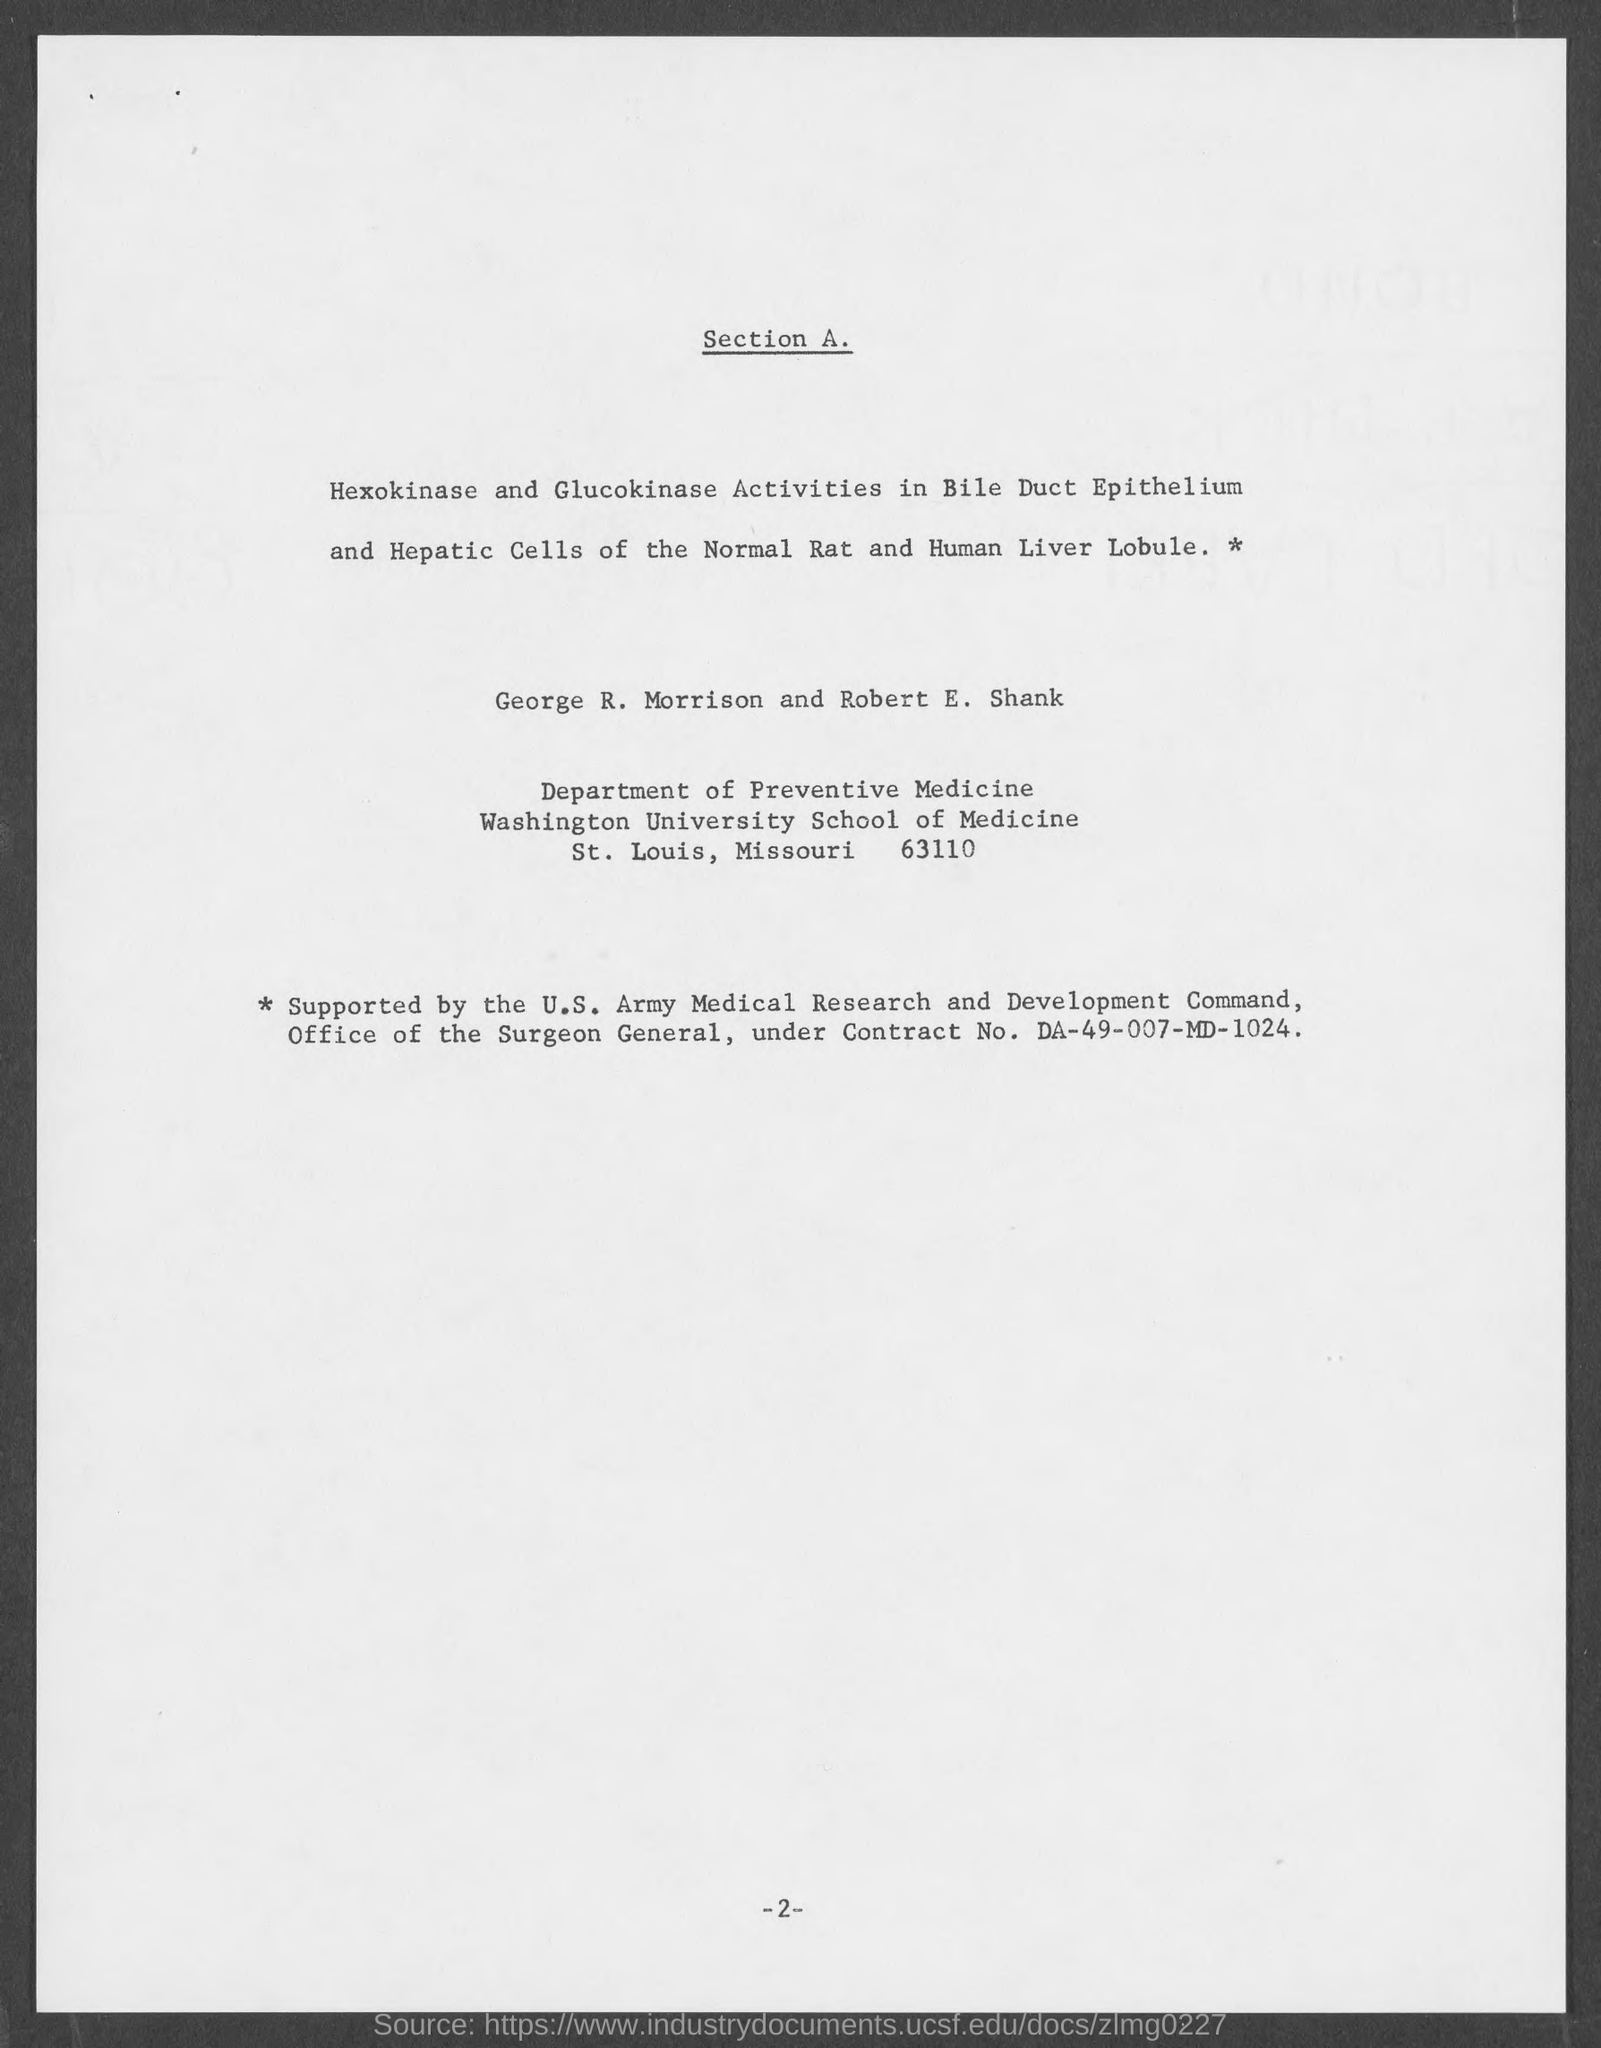List a handful of essential elements in this visual. George R. Morrison and Robert E. Shank are employed in the Department of Preventive Medicine. The Contract No. given in the document is DA-49-007-MD-1024... The page number mentioned in this document is 2. 